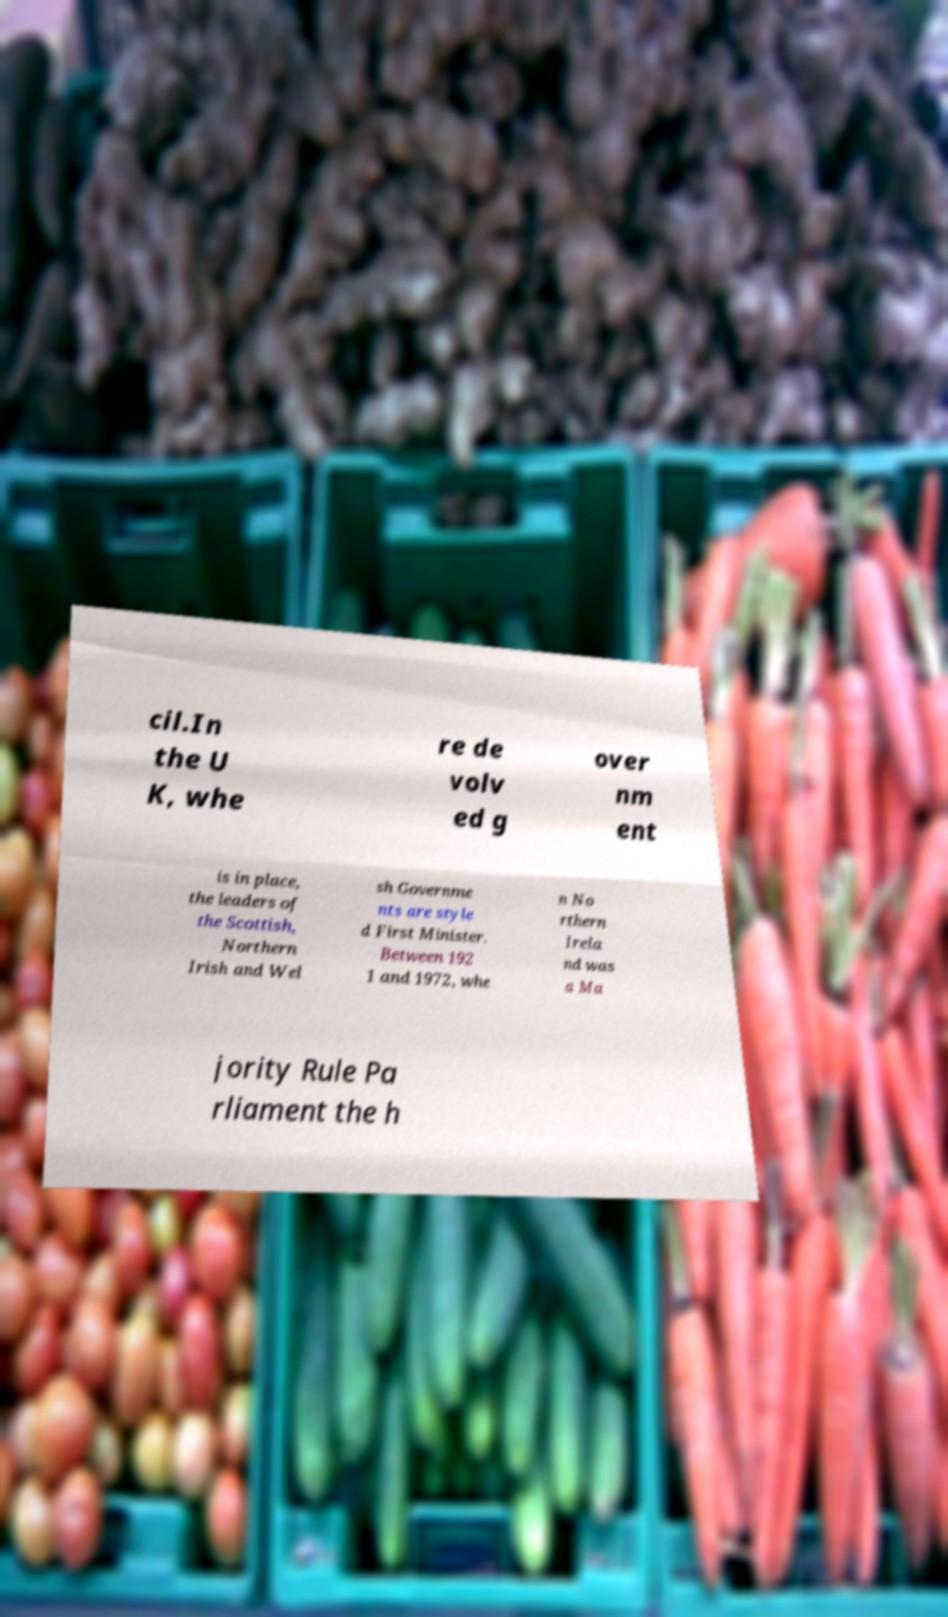Could you assist in decoding the text presented in this image and type it out clearly? cil.In the U K, whe re de volv ed g over nm ent is in place, the leaders of the Scottish, Northern Irish and Wel sh Governme nts are style d First Minister. Between 192 1 and 1972, whe n No rthern Irela nd was a Ma jority Rule Pa rliament the h 